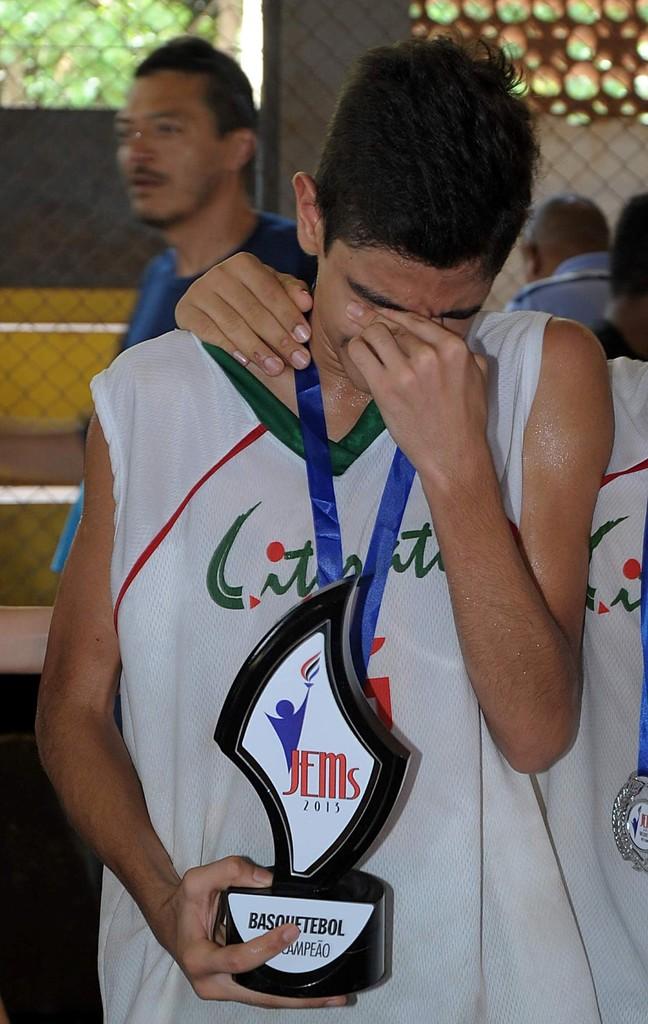What is the year on the trophy?
Your answer should be compact. 2015. 